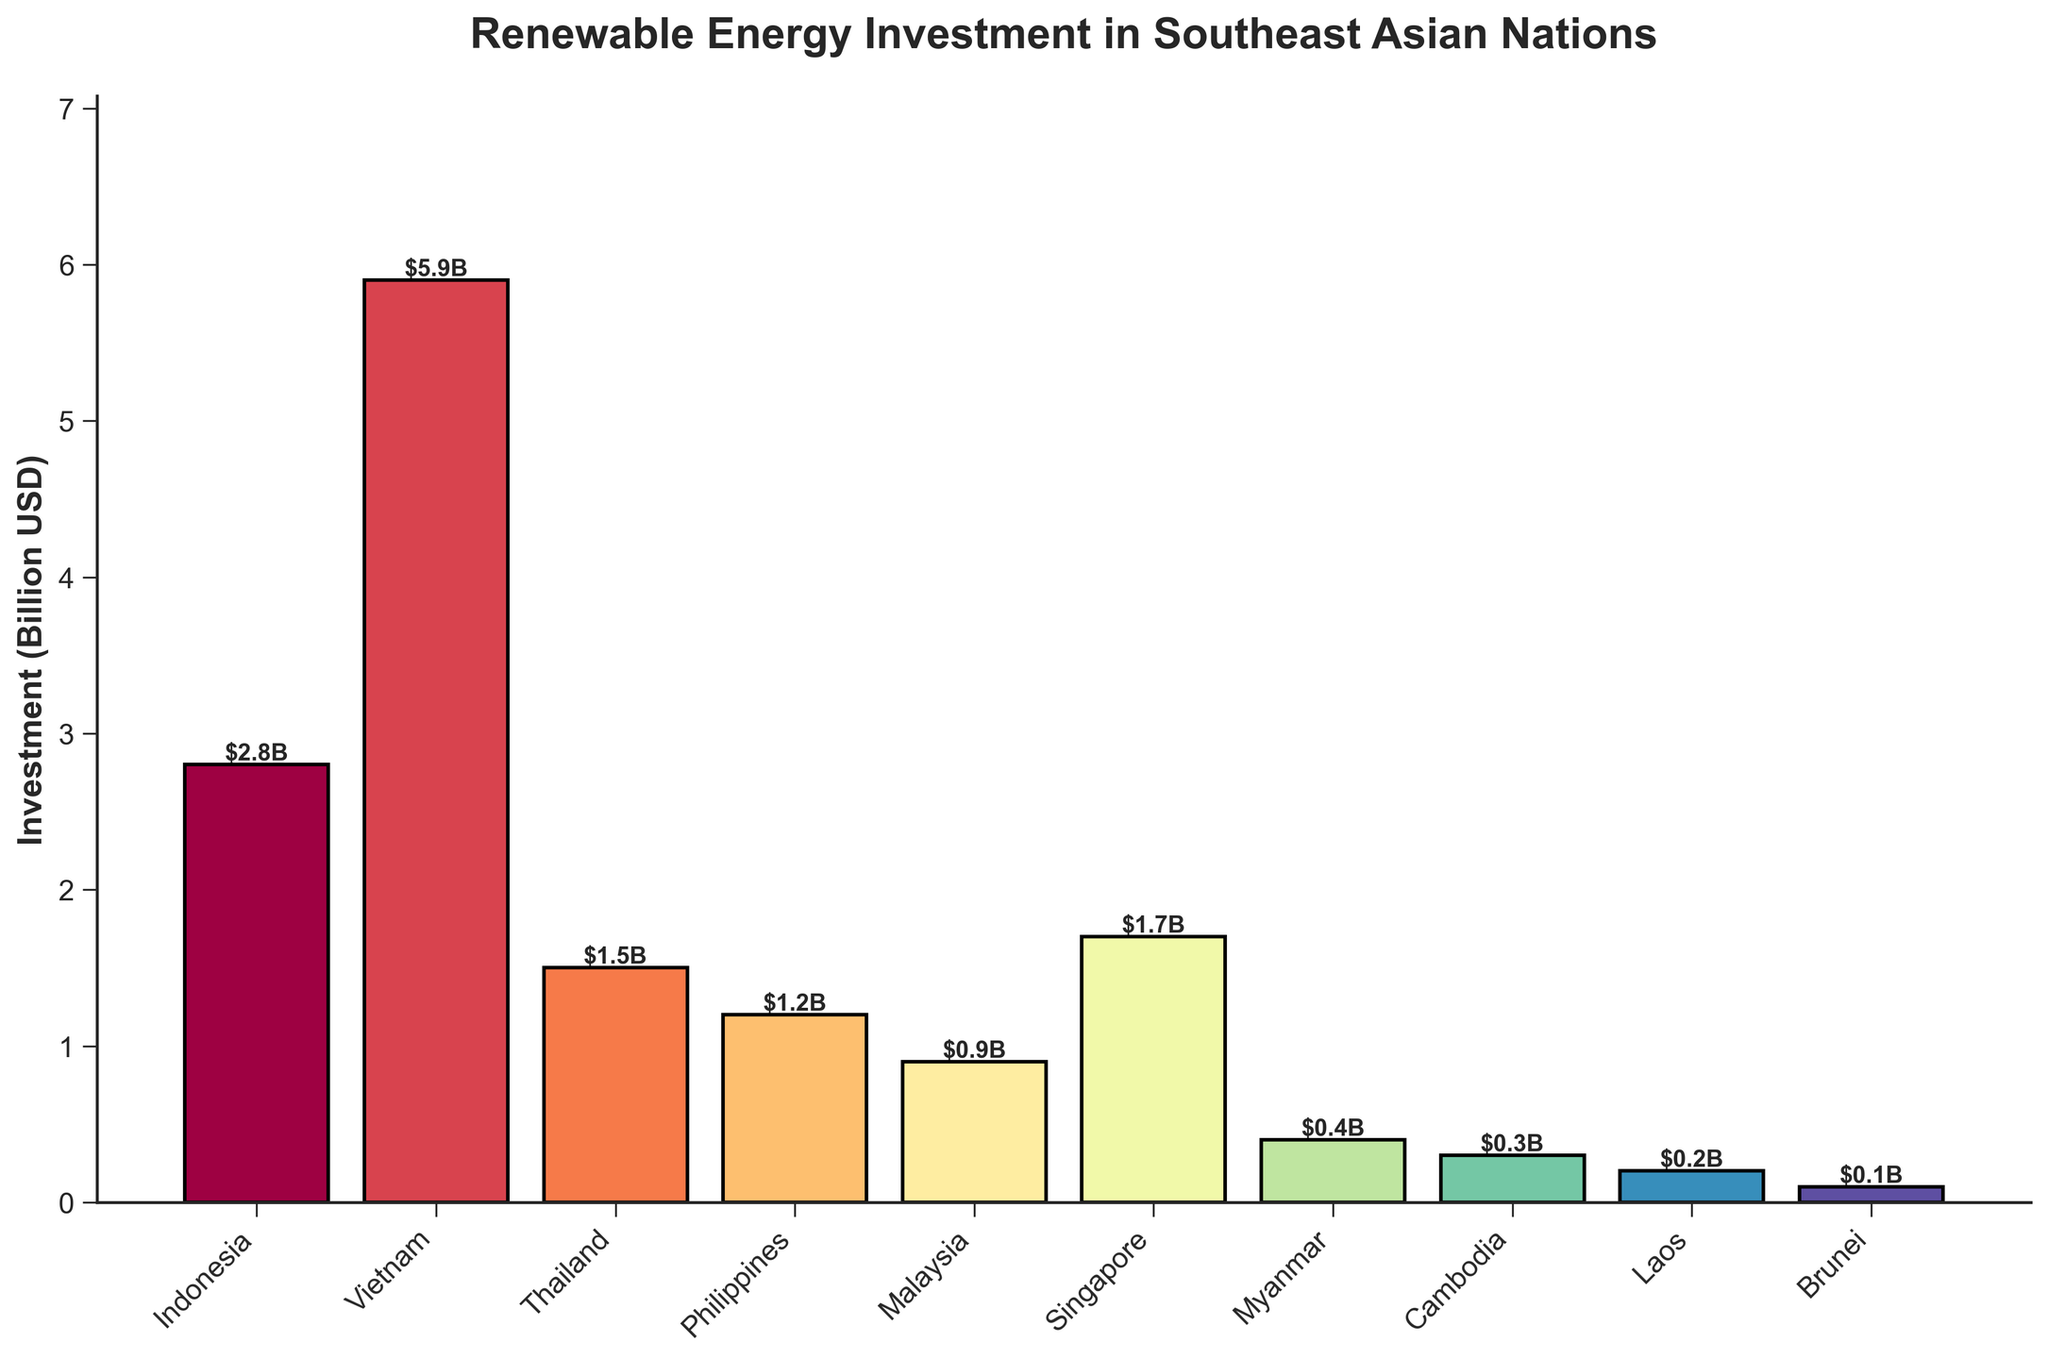What is the total investment in renewable energy for Thailand and Singapore combined? To find the total investment for both Thailand and Singapore, add their individual investments: 1.5 billion USD (Thailand) + 1.7 billion USD (Singapore) = 3.2 billion USD
Answer: 3.2 billion USD Which country has the highest investment in renewable energy, and how much is it? Identify the country with the tallest bar in the chart, which represents the highest investment. Vietnam's bar is the tallest, indicating it has the highest investment of 5.9 billion USD
Answer: Vietnam, 5.9 billion USD What is the average renewable energy investment for Indonesia, Malaysia, and Brunei? Sum the investments of Indonesia (2.8 billion USD), Malaysia (0.9 billion USD), and Brunei (0.1 billion USD) and then divide by 3: (2.8 + 0.9 + 0.1) / 3 = 3.8 / 3 ≈ 1.27 billion USD
Answer: 1.27 billion USD How much more investment is there in Vietnam compared to the Philippines? Subtract the investment of the Philippines (1.2 billion USD) from the investment of Vietnam (5.9 billion USD): 5.9 - 1.2 = 4.7 billion USD
Answer: 4.7 billion USD Which countries have investments that are less than 1 billion USD? Identify the countries with bars representing less than 1 billion USD. These countries are Brunei (0.1 billion USD), Laos (0.2 billion USD), Cambodia (0.3 billion USD), Myanmar (0.4 billion USD), Malaysia (0.9 billion USD), and the Philippines (1.2 billion USD is more than 1 billion so is excluded)
Answer: Brunei, Laos, Cambodia, Myanmar, Malaysia Compare the investments of the top two countries. What is the difference between their investments? The top two countries are Vietnam (5.9 billion USD) and Indonesia (2.8 billion USD). Subtract Indonesia's investment from Vietnam's investment: 5.9 - 2.8 = 3.1 billion USD
Answer: 3.1 billion USD Which country has the least investment in renewable energy, and what is its value? Identify the country with the shortest bar in the chart. Brunei's bar is the shortest with an investment value of 0.1 billion USD
Answer: Brunei, 0.1 billion USD What is the sum of investments for countries with more than 1 billion USD in renewable energy? Identify the countries with investments greater than 1 billion USD: Indonesia (2.8 billion USD), Vietnam (5.9 billion USD), Thailand (1.5 billion USD), Philippines (1.2 billion USD), Singapore (1.7 billion USD). Sum these values: 2.8 + 5.9 + 1.5 + 1.2 + 1.7 = 13.1 billion USD
Answer: 13.1 billion USD How does the average investment for Myanmar, Cambodia, and Laos compare to that of Malaysia? First, calculate the average for Myanmar (0.4 billion USD), Cambodia (0.3 billion USD), and Laos (0.2 billion USD): (0.4 + 0.3 + 0.2) / 3 = 0.9 / 3 = 0.3 billion USD. Then, compare it to Malaysia's investment (0.9 billion USD). The average investment (0.3 billion USD) is less than Malaysia's investment (0.9 billion USD)
Answer: The average of Myanmar, Cambodia, and Laos (0.3 billion USD) is less than Malaysia (0.9 billion USD) What percentage of the total investment does Vietnam contribute? First, calculate the total investment from all countries: 2.8 + 5.9 + 1.5 + 1.2 + 0.9 + 1.7 + 0.4 + 0.3 + 0.2 + 0.1 = 15 billion USD. Then, find the percentage Vietnam's investment (5.9 billion USD) contributes: (5.9 / 15) * 100 ≈ 39.33%
Answer: 39.33% 